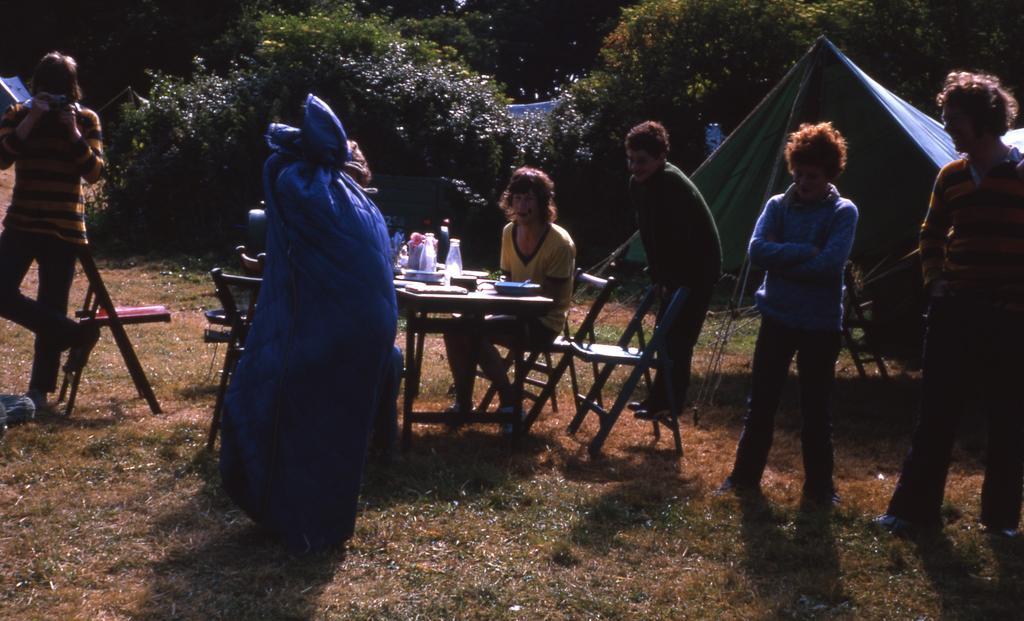Describe this image in one or two sentences. It seems to the image is a inside a garden. In middle of the image there is a woman sitting on chair in front of a table, on table we can see some bottles,box. On right side there are three men's are standing, on left side there is a person standing. In background we can see a tent trees at bottom there is a grass. 